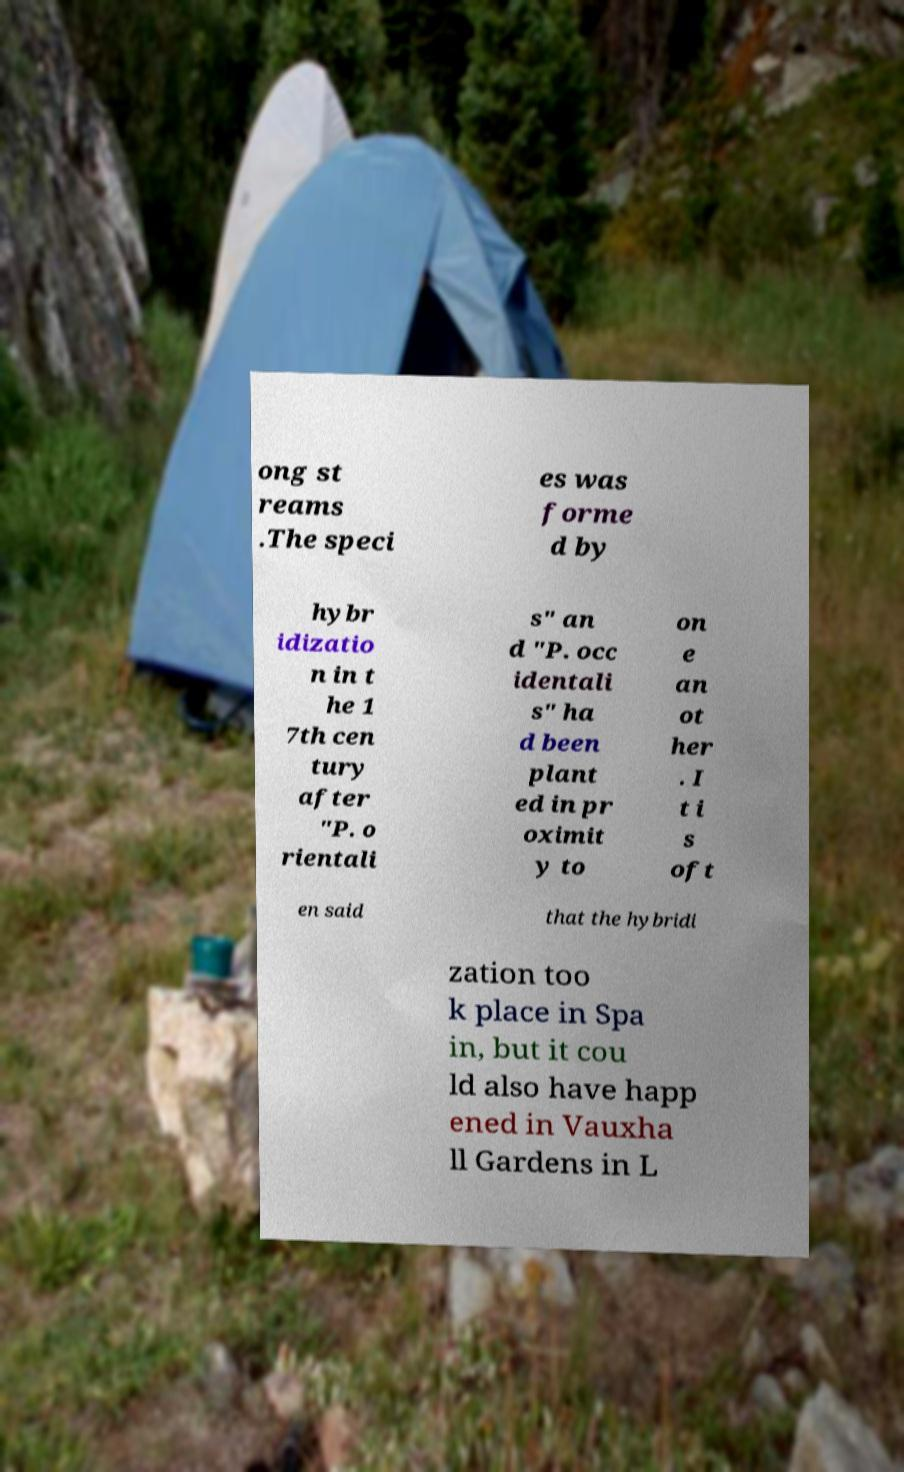Please identify and transcribe the text found in this image. ong st reams .The speci es was forme d by hybr idizatio n in t he 1 7th cen tury after "P. o rientali s" an d "P. occ identali s" ha d been plant ed in pr oximit y to on e an ot her . I t i s oft en said that the hybridi zation too k place in Spa in, but it cou ld also have happ ened in Vauxha ll Gardens in L 